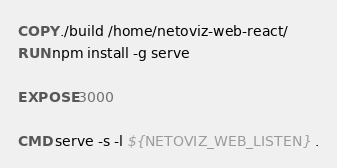<code> <loc_0><loc_0><loc_500><loc_500><_Dockerfile_>COPY ./build /home/netoviz-web-react/
RUN npm install -g serve

EXPOSE 3000

CMD serve -s -l ${NETOVIZ_WEB_LISTEN} .
</code> 